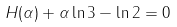<formula> <loc_0><loc_0><loc_500><loc_500>H ( \alpha ) + \alpha \ln 3 - \ln 2 = 0</formula> 